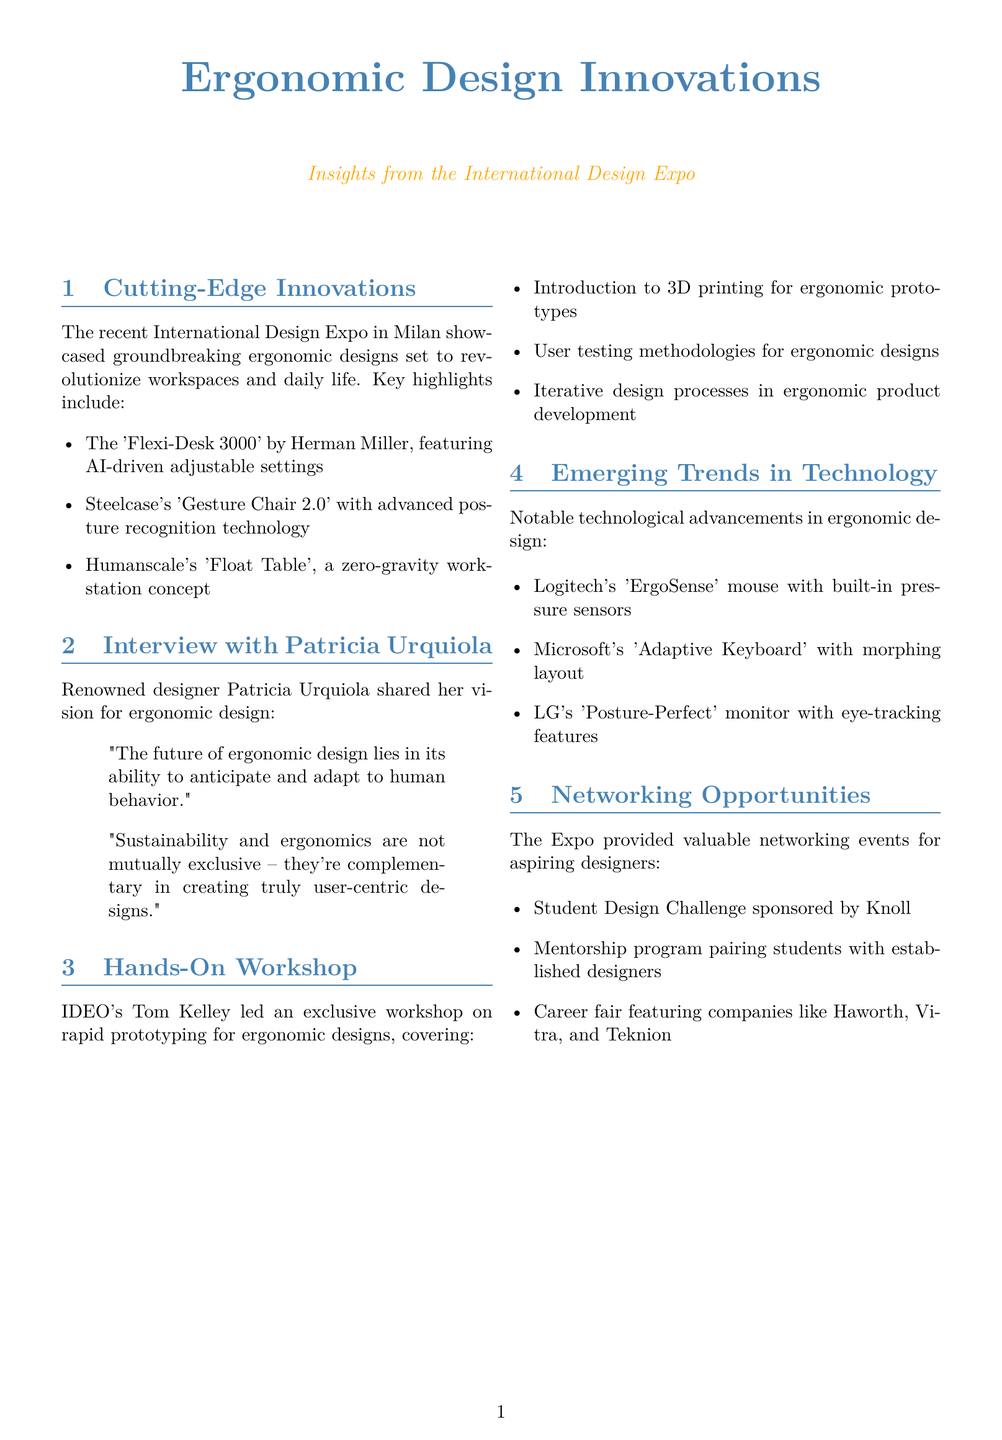What is the title of the newsletter? The title is presented at the beginning of the document, highlighting the focus on ergonomic design innovations.
Answer: Ergonomic Design Innovations Who is the designer featured in the interview section? The document specifically names the designer interviewed regarding ergonomic design.
Answer: Patricia Urquiola What company developed the 'Flexi-Desk 3000'? The document lists the creator of this innovative desk, which is mentioned in the key highlights.
Answer: Herman Miller How many key highlights were mentioned under Cutting-Edge Innovations? The document lists a total of three key highlights related to ergonomic innovations.
Answer: Three What technology does Microsoft's 'Adaptive Keyboard' utilize? The document describes the unique functionality of this keyboard concerning user behavior.
Answer: Morphing layout Which company sponsored the Student Design Challenge? The document identifies the sponsor of this design challenge aiming at students.
Answer: Knoll What is one of the workshop highlights mentioned in the Hands-On Workshop section? The document outlines key components discussed during the workshop led by Tom Kelley.
Answer: 3D printing for ergonomic prototypes What is emphasized as crucial for young designers in Urquiola's interview? The document conveys a key point about interdisciplinary approaches suggested by the featured designer.
Answer: Interdisciplinary approaches How many notable technologies were presented in the Emerging Trends section? The document enumerates three notable technological advancements in ergonomic design.
Answer: Three 